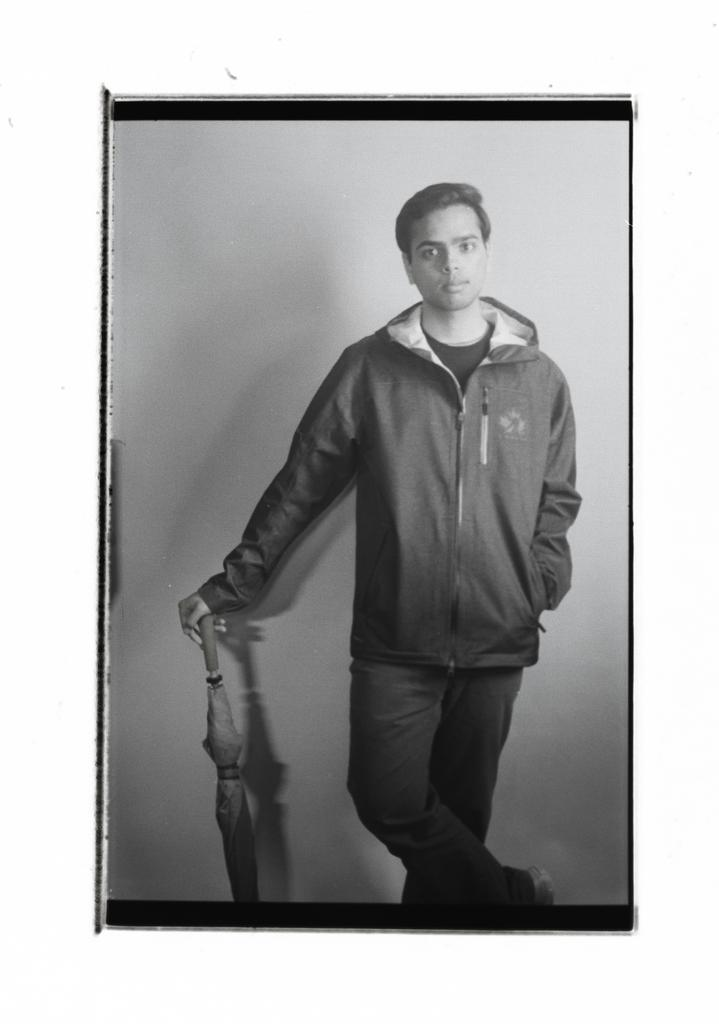What is the main subject of the image? There is a man standing in the image. What object is present in the image besides the man? There is an umbrella in the image. What is the color scheme of the image? The image is black and white in color. What type of tank can be seen in the image? There is no tank present in the image. How does the man show respect in the image? The image does not depict any actions or expressions that indicate respect. 